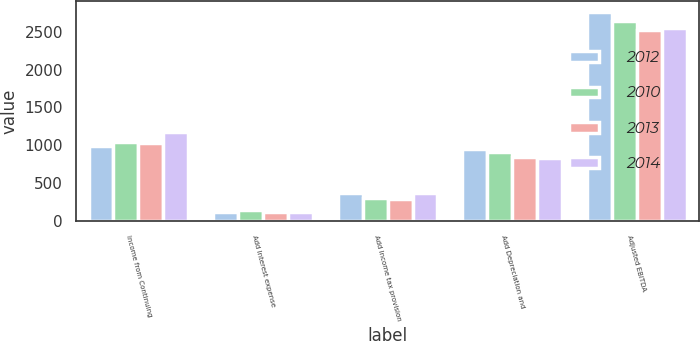Convert chart. <chart><loc_0><loc_0><loc_500><loc_500><stacked_bar_chart><ecel><fcel>Income from Continuing<fcel>Add Interest expense<fcel>Add Income tax provision<fcel>Add Depreciation and<fcel>Adjusted EBITDA<nl><fcel>2012<fcel>988.5<fcel>125.1<fcel>366<fcel>956.9<fcel>2764.8<nl><fcel>2010<fcel>1042.5<fcel>141.8<fcel>307.9<fcel>907<fcel>2640.9<nl><fcel>2013<fcel>1025.2<fcel>123.7<fcel>287.3<fcel>840.8<fcel>2528.3<nl><fcel>2014<fcel>1171.6<fcel>115.5<fcel>375.3<fcel>834.3<fcel>2545.2<nl></chart> 